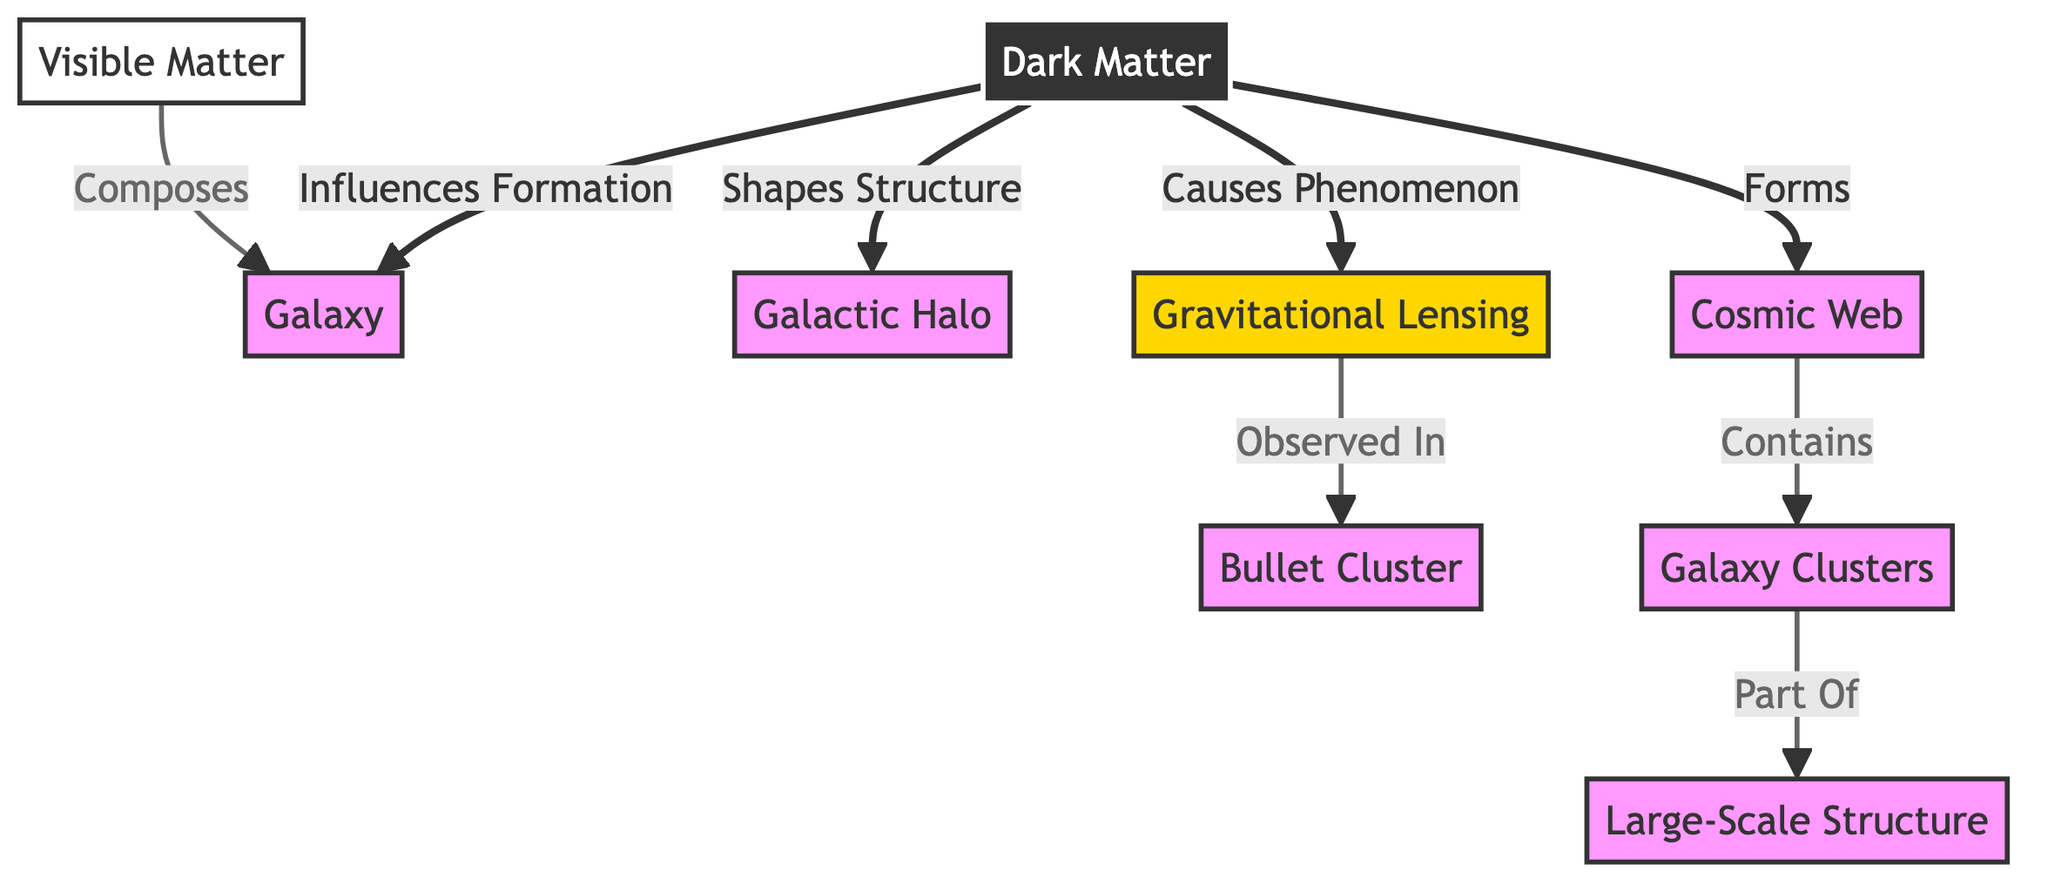What is the role of Dark Matter in the diagram? Dark Matter influences the formation of galaxies, shapes the structure of galactic halos, and causes phenomena like gravitational lensing. It also forms the cosmic web.
Answer: Influences formation, shapes structure, causes phenomenon, forms What does Visible Matter compose? According to the diagram, visible matter is indicated to compose the galaxies directly.
Answer: Galaxy How many different types of matter are represented in the diagram? There are two types of matter represented: Dark Matter and Visible Matter.
Answer: Two What phenomenon is observed in the Bullet Cluster? Gravitational lensing is observed in the Bullet Cluster, showing the influence of dark matter in that context.
Answer: Gravitational Lensing What is the relationship between Cosmic Web and Galaxy Clusters? The Cosmic Web contains galaxy clusters, indicating its role as a structure holding together clusters of galaxies.
Answer: Contains How does Dark Matter relate to Large-Scale Structure? Dark matter leads to the formation of cosmic structures such as galaxy clusters, which are part of the larger scale structure of the universe.
Answer: Part of What does Gravitational Lensing indicate in the diagram? Gravitational lensing indicates the effect caused by dark matter, highlighting its presence through observable phenomena in specific clusters like the Bullet Cluster.
Answer: Cause of phenomenon In the context of this diagram, what does the term "Galactic Halo" refer to? The Galactic Halo refers to the structure shaped by dark matter, which surrounds a galaxy and is influential in its formation and dynamics.
Answer: Shapes structure What constitutes the Large-Scale Structure in the diagram? The Large-Scale Structure is composed of galaxy clusters formed within the cosmic web, influenced by the distribution of dark matter.
Answer: Part of 